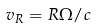Convert formula to latex. <formula><loc_0><loc_0><loc_500><loc_500>v _ { R } = R \Omega / c</formula> 